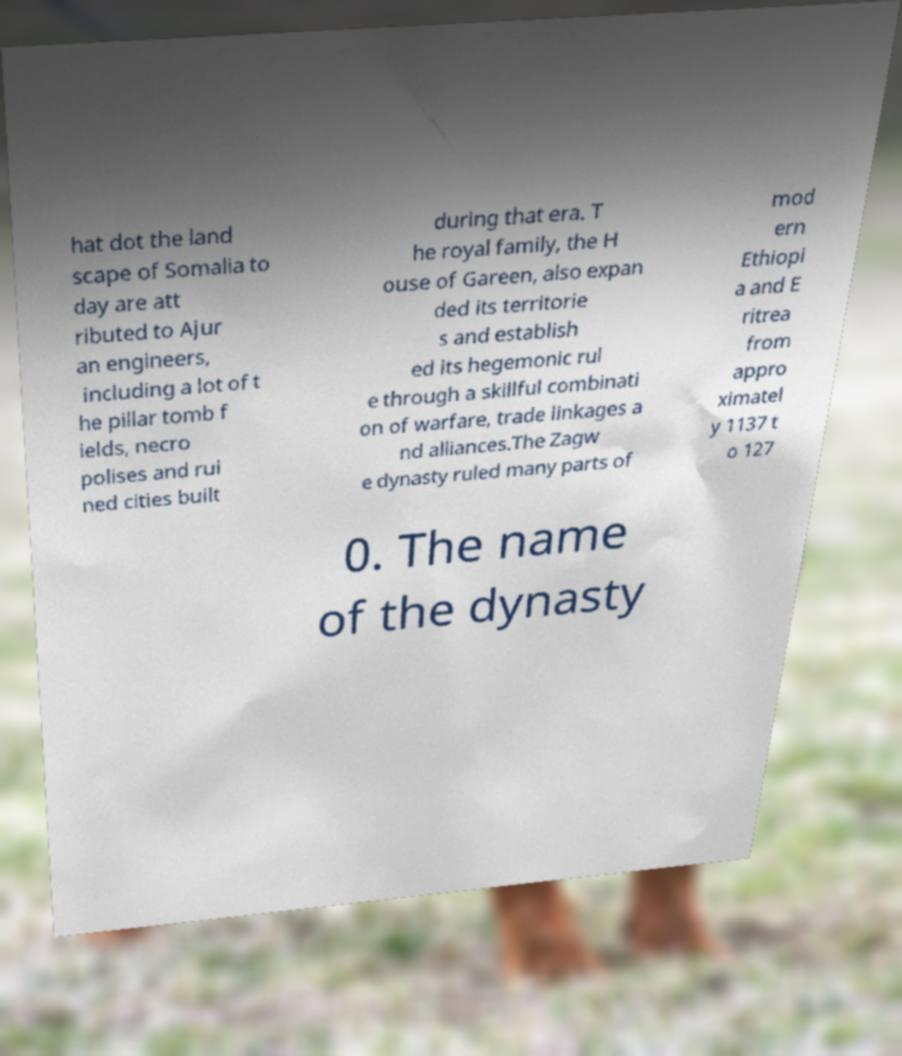Please read and relay the text visible in this image. What does it say? hat dot the land scape of Somalia to day are att ributed to Ajur an engineers, including a lot of t he pillar tomb f ields, necro polises and rui ned cities built during that era. T he royal family, the H ouse of Gareen, also expan ded its territorie s and establish ed its hegemonic rul e through a skillful combinati on of warfare, trade linkages a nd alliances.The Zagw e dynasty ruled many parts of mod ern Ethiopi a and E ritrea from appro ximatel y 1137 t o 127 0. The name of the dynasty 